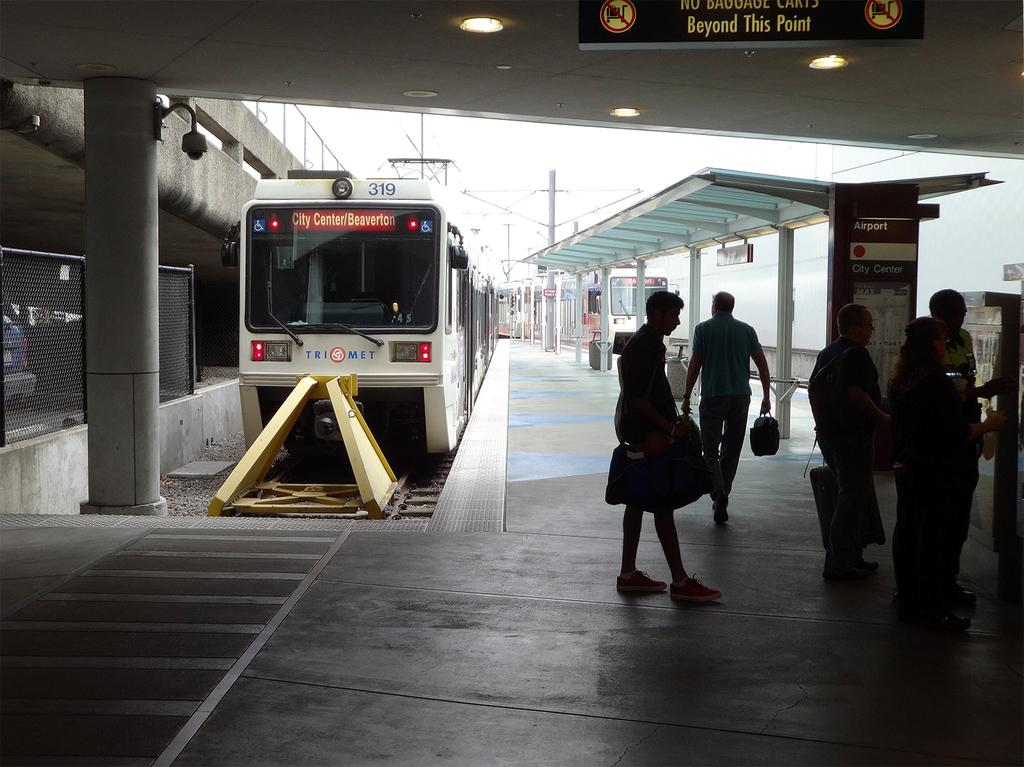Provide a one-sentence caption for the provided image. A dark picture of a train station with people standing below a warning sign while a train parked that has arrived at Beaverton city centre sits behind them. 